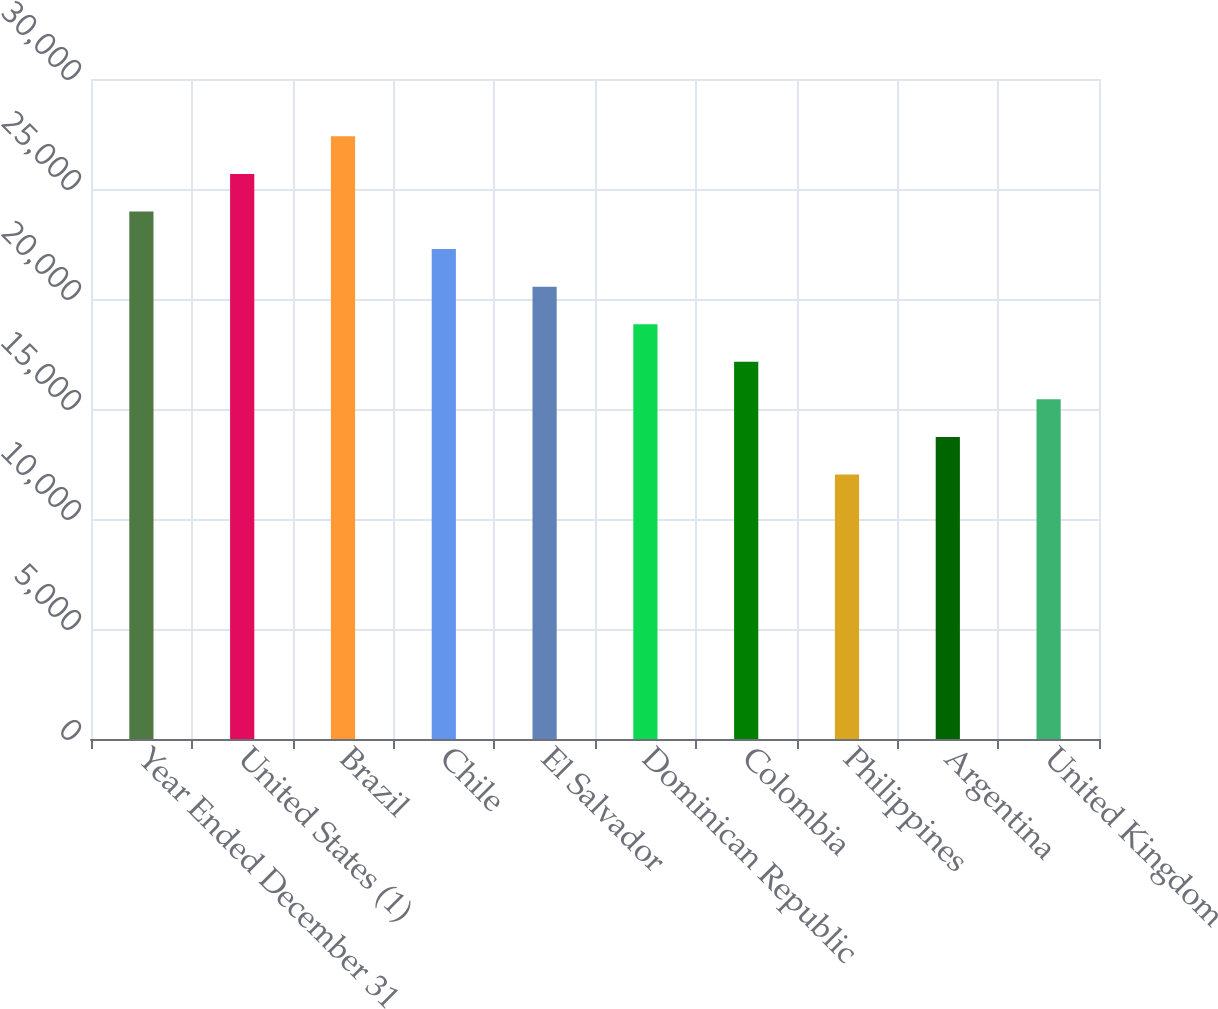Convert chart to OTSL. <chart><loc_0><loc_0><loc_500><loc_500><bar_chart><fcel>Year Ended December 31<fcel>United States (1)<fcel>Brazil<fcel>Chile<fcel>El Salvador<fcel>Dominican Republic<fcel>Colombia<fcel>Philippines<fcel>Argentina<fcel>United Kingdom<nl><fcel>23977.6<fcel>25685.5<fcel>27393.4<fcel>22269.7<fcel>20561.8<fcel>18853.9<fcel>17146<fcel>12022.3<fcel>13730.2<fcel>15438.1<nl></chart> 